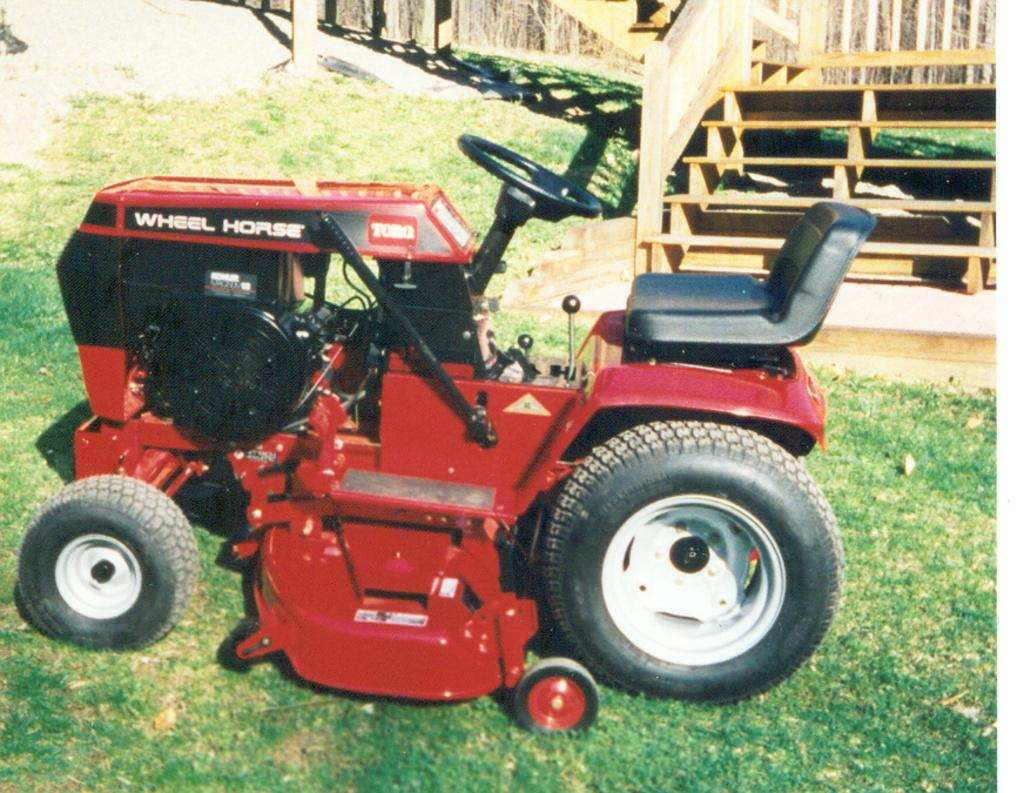What is placed on the grass in the image? There is a track placed on the grass in the image. What type of stairs can be seen in the image? There are wooden stairs visible in the image. Is there any safety feature associated with the wooden stairs? Yes, there is a railing associated with the wooden stairs. What type of detail can be seen burning in the image? There is no detail present in the image that is burning. 